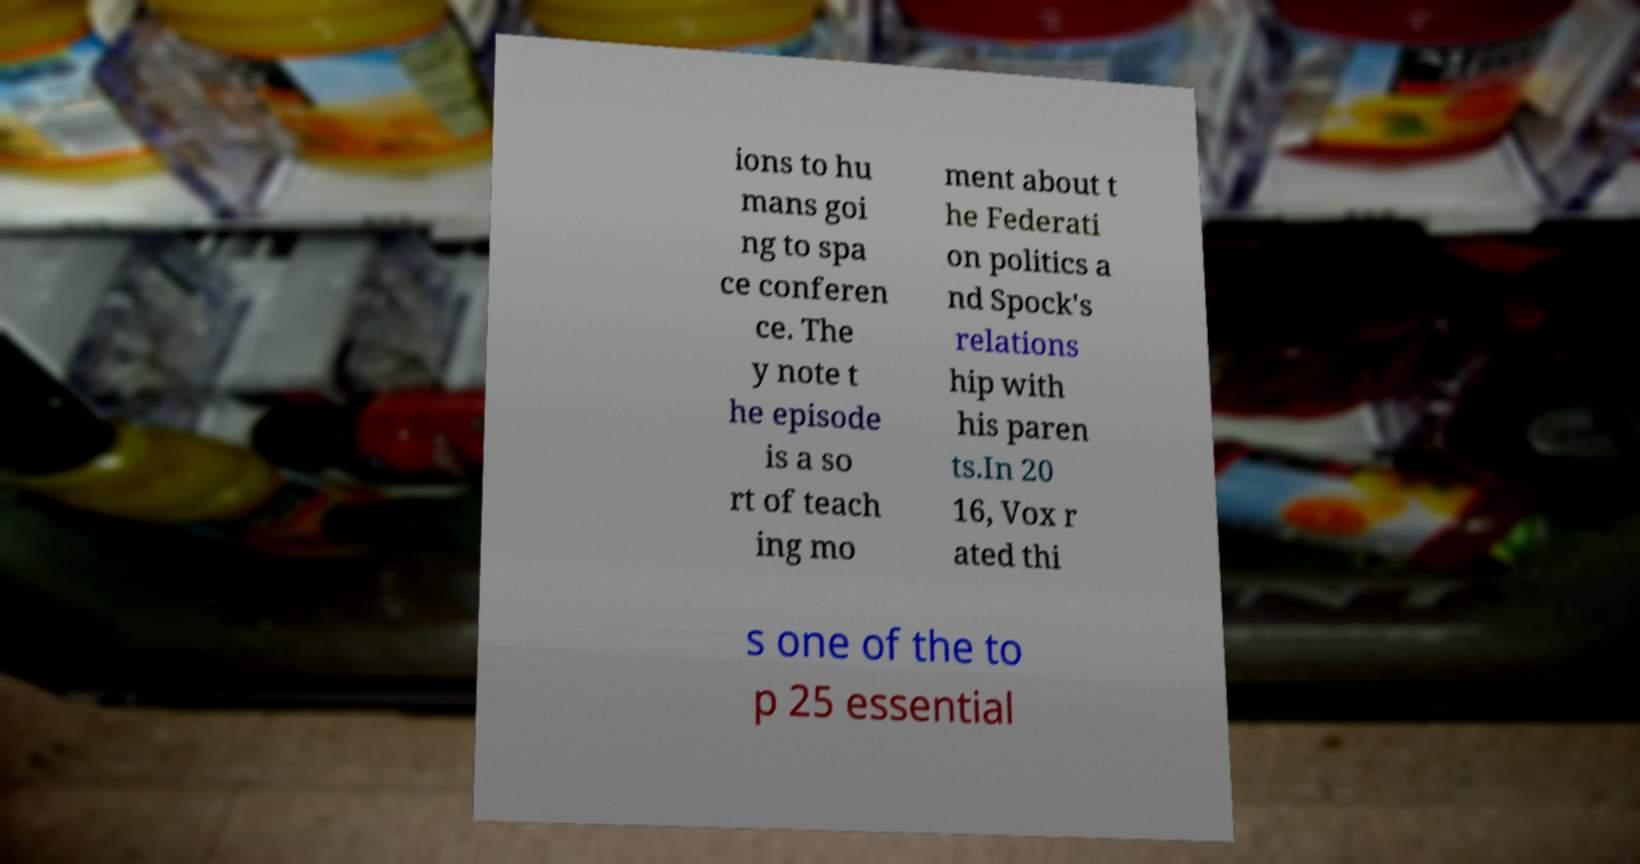There's text embedded in this image that I need extracted. Can you transcribe it verbatim? ions to hu mans goi ng to spa ce conferen ce. The y note t he episode is a so rt of teach ing mo ment about t he Federati on politics a nd Spock's relations hip with his paren ts.In 20 16, Vox r ated thi s one of the to p 25 essential 